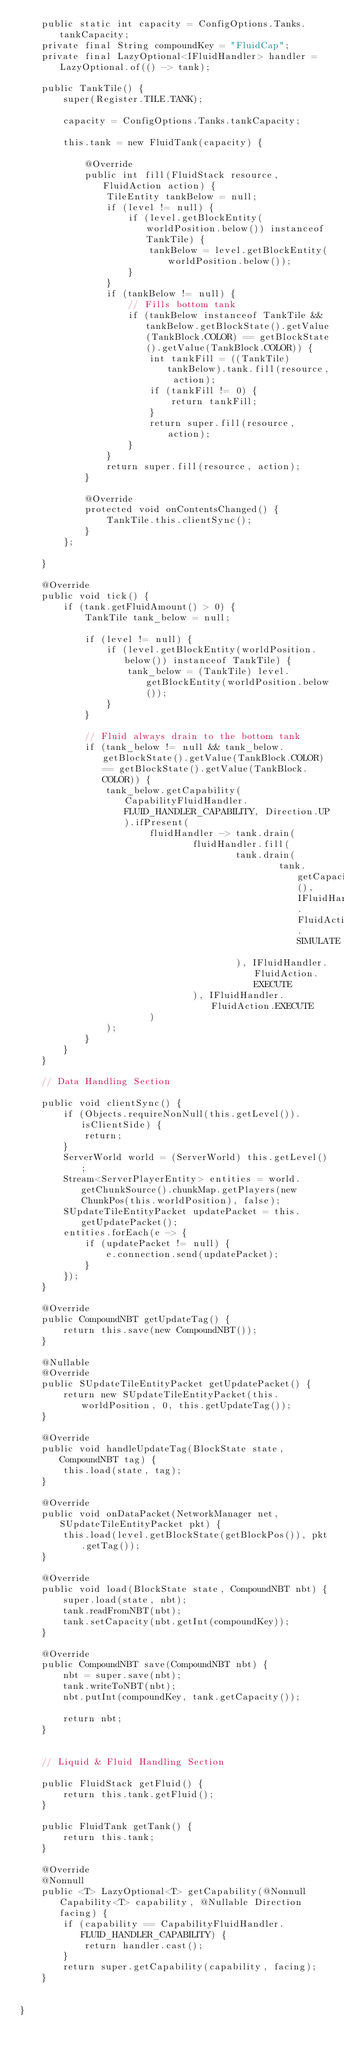<code> <loc_0><loc_0><loc_500><loc_500><_Java_>    public static int capacity = ConfigOptions.Tanks.tankCapacity;
    private final String compoundKey = "FluidCap";
    private final LazyOptional<IFluidHandler> handler = LazyOptional.of(() -> tank);

    public TankTile() {
        super(Register.TILE.TANK);

        capacity = ConfigOptions.Tanks.tankCapacity;

        this.tank = new FluidTank(capacity) {

            @Override
            public int fill(FluidStack resource, FluidAction action) {
                TileEntity tankBelow = null;
                if (level != null) {
                    if (level.getBlockEntity(worldPosition.below()) instanceof TankTile) {
                        tankBelow = level.getBlockEntity(worldPosition.below());
                    }
                }
                if (tankBelow != null) {
                    // Fills bottom tank
                    if (tankBelow instanceof TankTile && tankBelow.getBlockState().getValue(TankBlock.COLOR) == getBlockState().getValue(TankBlock.COLOR)) {
                        int tankFill = ((TankTile) tankBelow).tank.fill(resource, action);
                        if (tankFill != 0) {
                            return tankFill;
                        }
                        return super.fill(resource, action);
                    }
                }
                return super.fill(resource, action);
            }

            @Override
            protected void onContentsChanged() {
                TankTile.this.clientSync();
            }
        };

    }

    @Override
    public void tick() {
        if (tank.getFluidAmount() > 0) {
            TankTile tank_below = null;

            if (level != null) {
                if (level.getBlockEntity(worldPosition.below()) instanceof TankTile) {
                    tank_below = (TankTile) level.getBlockEntity(worldPosition.below());
                }
            }

            // Fluid always drain to the bottom tank
            if (tank_below != null && tank_below.getBlockState().getValue(TankBlock.COLOR) == getBlockState().getValue(TankBlock.COLOR)) {
                tank_below.getCapability(CapabilityFluidHandler.FLUID_HANDLER_CAPABILITY, Direction.UP).ifPresent(
                        fluidHandler -> tank.drain(
                                fluidHandler.fill(
                                        tank.drain(
                                                tank.getCapacity(), IFluidHandler.FluidAction.SIMULATE
                                        ), IFluidHandler.FluidAction.EXECUTE
                                ), IFluidHandler.FluidAction.EXECUTE
                        )
                );
            }
        }
    }

    // Data Handling Section

    public void clientSync() {
        if (Objects.requireNonNull(this.getLevel()).isClientSide) {
            return;
        }
        ServerWorld world = (ServerWorld) this.getLevel();
        Stream<ServerPlayerEntity> entities = world.getChunkSource().chunkMap.getPlayers(new ChunkPos(this.worldPosition), false);
        SUpdateTileEntityPacket updatePacket = this.getUpdatePacket();
        entities.forEach(e -> {
            if (updatePacket != null) {
                e.connection.send(updatePacket);
            }
        });
    }

    @Override
    public CompoundNBT getUpdateTag() {
        return this.save(new CompoundNBT());
    }

    @Nullable
    @Override
    public SUpdateTileEntityPacket getUpdatePacket() {
        return new SUpdateTileEntityPacket(this.worldPosition, 0, this.getUpdateTag());
    }

    @Override
    public void handleUpdateTag(BlockState state, CompoundNBT tag) {
        this.load(state, tag);
    }

    @Override
    public void onDataPacket(NetworkManager net, SUpdateTileEntityPacket pkt) {
        this.load(level.getBlockState(getBlockPos()), pkt.getTag());
    }

    @Override
    public void load(BlockState state, CompoundNBT nbt) {
        super.load(state, nbt);
        tank.readFromNBT(nbt);
        tank.setCapacity(nbt.getInt(compoundKey));
    }

    @Override
    public CompoundNBT save(CompoundNBT nbt) {
        nbt = super.save(nbt);
        tank.writeToNBT(nbt);
        nbt.putInt(compoundKey, tank.getCapacity());

        return nbt;
    }


    // Liquid & Fluid Handling Section

    public FluidStack getFluid() {
        return this.tank.getFluid();
    }

    public FluidTank getTank() {
        return this.tank;
    }

    @Override
    @Nonnull
    public <T> LazyOptional<T> getCapability(@Nonnull Capability<T> capability, @Nullable Direction facing) {
        if (capability == CapabilityFluidHandler.FLUID_HANDLER_CAPABILITY) {
            return handler.cast();
        }
        return super.getCapability(capability, facing);
    }


}
</code> 